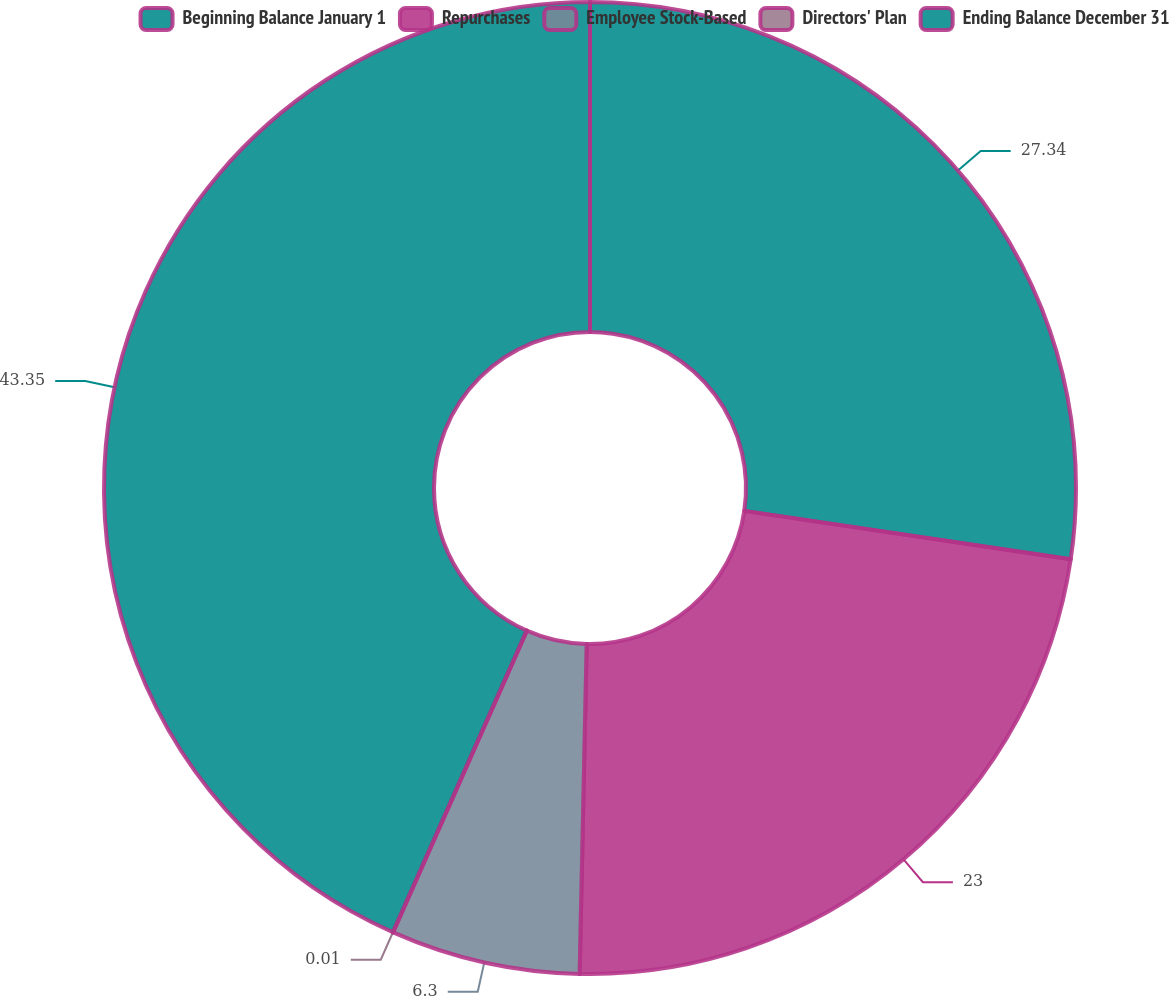Convert chart. <chart><loc_0><loc_0><loc_500><loc_500><pie_chart><fcel>Beginning Balance January 1<fcel>Repurchases<fcel>Employee Stock-Based<fcel>Directors' Plan<fcel>Ending Balance December 31<nl><fcel>27.34%<fcel>23.0%<fcel>6.3%<fcel>0.01%<fcel>43.35%<nl></chart> 